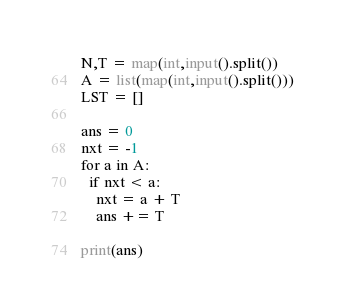Convert code to text. <code><loc_0><loc_0><loc_500><loc_500><_Python_>N,T = map(int,input().split())
A = list(map(int,input().split()))
LST = []

ans = 0
nxt = -1
for a in A:
  if nxt < a:
    nxt = a + T
    ans += T
  
print(ans)

</code> 